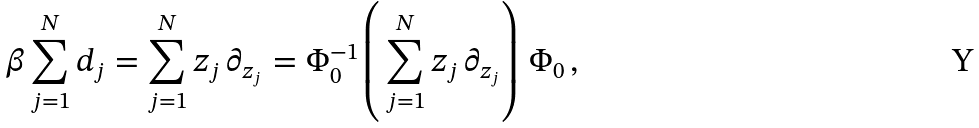<formula> <loc_0><loc_0><loc_500><loc_500>\beta \sum _ { j = 1 } ^ { N } d _ { j } = \sum _ { j = 1 } ^ { N } z _ { j } \, \partial _ { z _ { j } } = \Phi _ { 0 } ^ { - 1 } \left ( \, \sum _ { j = 1 } ^ { N } z _ { j } \, \partial _ { z _ { j } } \right ) \, \Phi _ { 0 } \, ,</formula> 